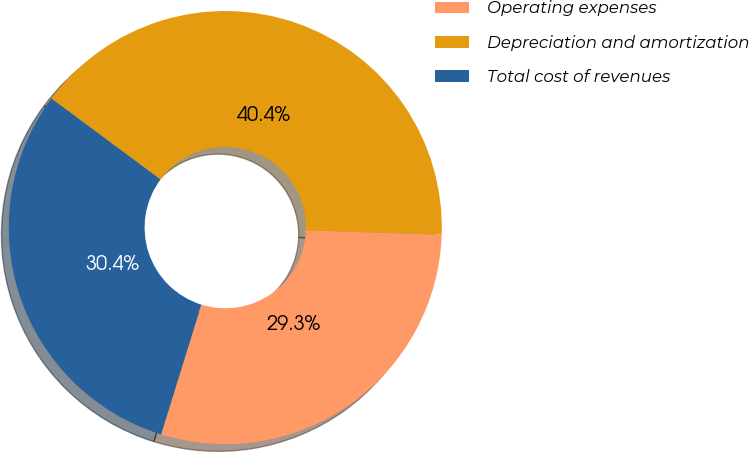<chart> <loc_0><loc_0><loc_500><loc_500><pie_chart><fcel>Operating expenses<fcel>Depreciation and amortization<fcel>Total cost of revenues<nl><fcel>29.26%<fcel>40.36%<fcel>30.37%<nl></chart> 